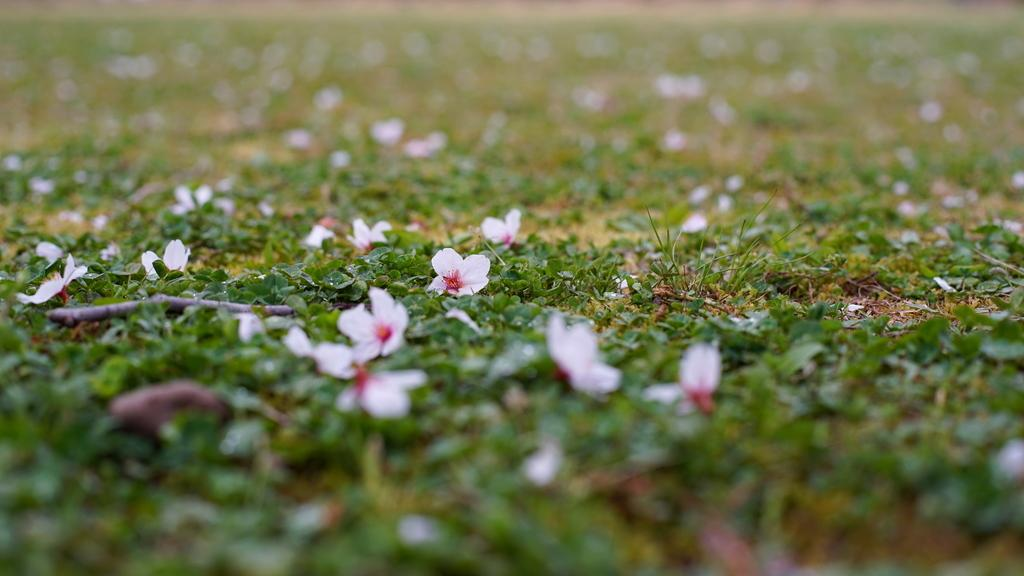What is present at the bottom of the image? There are flowers and leafs at the bottom of the image. What type of creature can be seen interacting with the flowers at the bottom of the image? There is no creature present in the image; it only features flowers and leafs. What type of pump is visible in the image? There is no pump present in the image. 